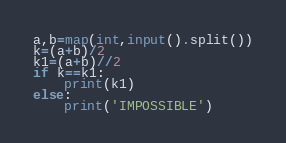Convert code to text. <code><loc_0><loc_0><loc_500><loc_500><_Python_>a,b=map(int,input().split())
k=(a+b)/2
k1=(a+b)//2
if k==k1:
    print(k1)
else:
    print('IMPOSSIBLE')
</code> 